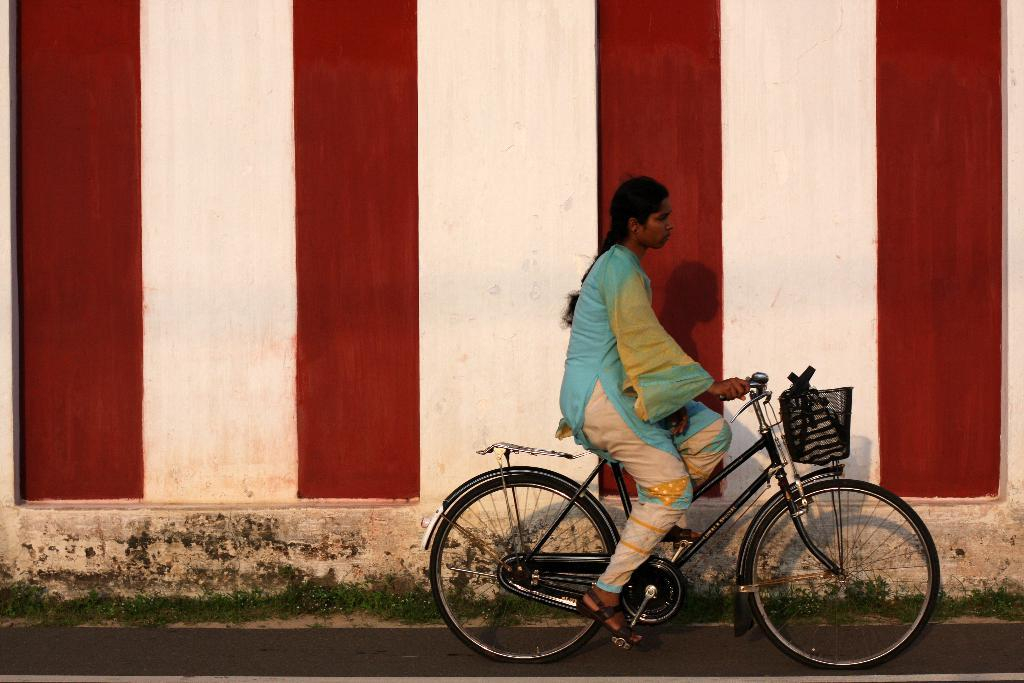Who is the main subject in the image? There is a woman in the image. What is the woman doing in the image? The woman is riding a bicycle. Where is the bicycle located? The bicycle is on a road. What can be seen in the background of the image? There is a wall in the background of the image. How many dolls are sitting on the wall in the image? There are no dolls present in the image; it features a woman riding a bicycle on a road with a wall in the background. 